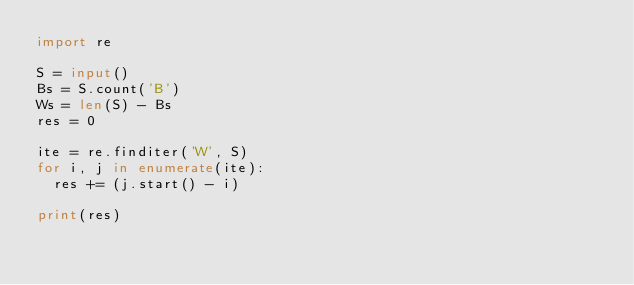Convert code to text. <code><loc_0><loc_0><loc_500><loc_500><_Python_>import re

S = input()
Bs = S.count('B')
Ws = len(S) - Bs
res = 0

ite = re.finditer('W', S)
for i, j in enumerate(ite):
  res += (j.start() - i)
  
print(res)</code> 